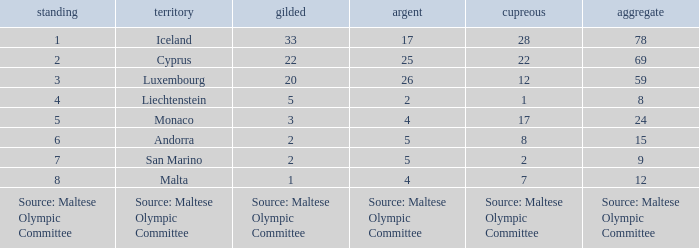What is the number of gold medals when the number of bronze medals is 8? 2.0. 